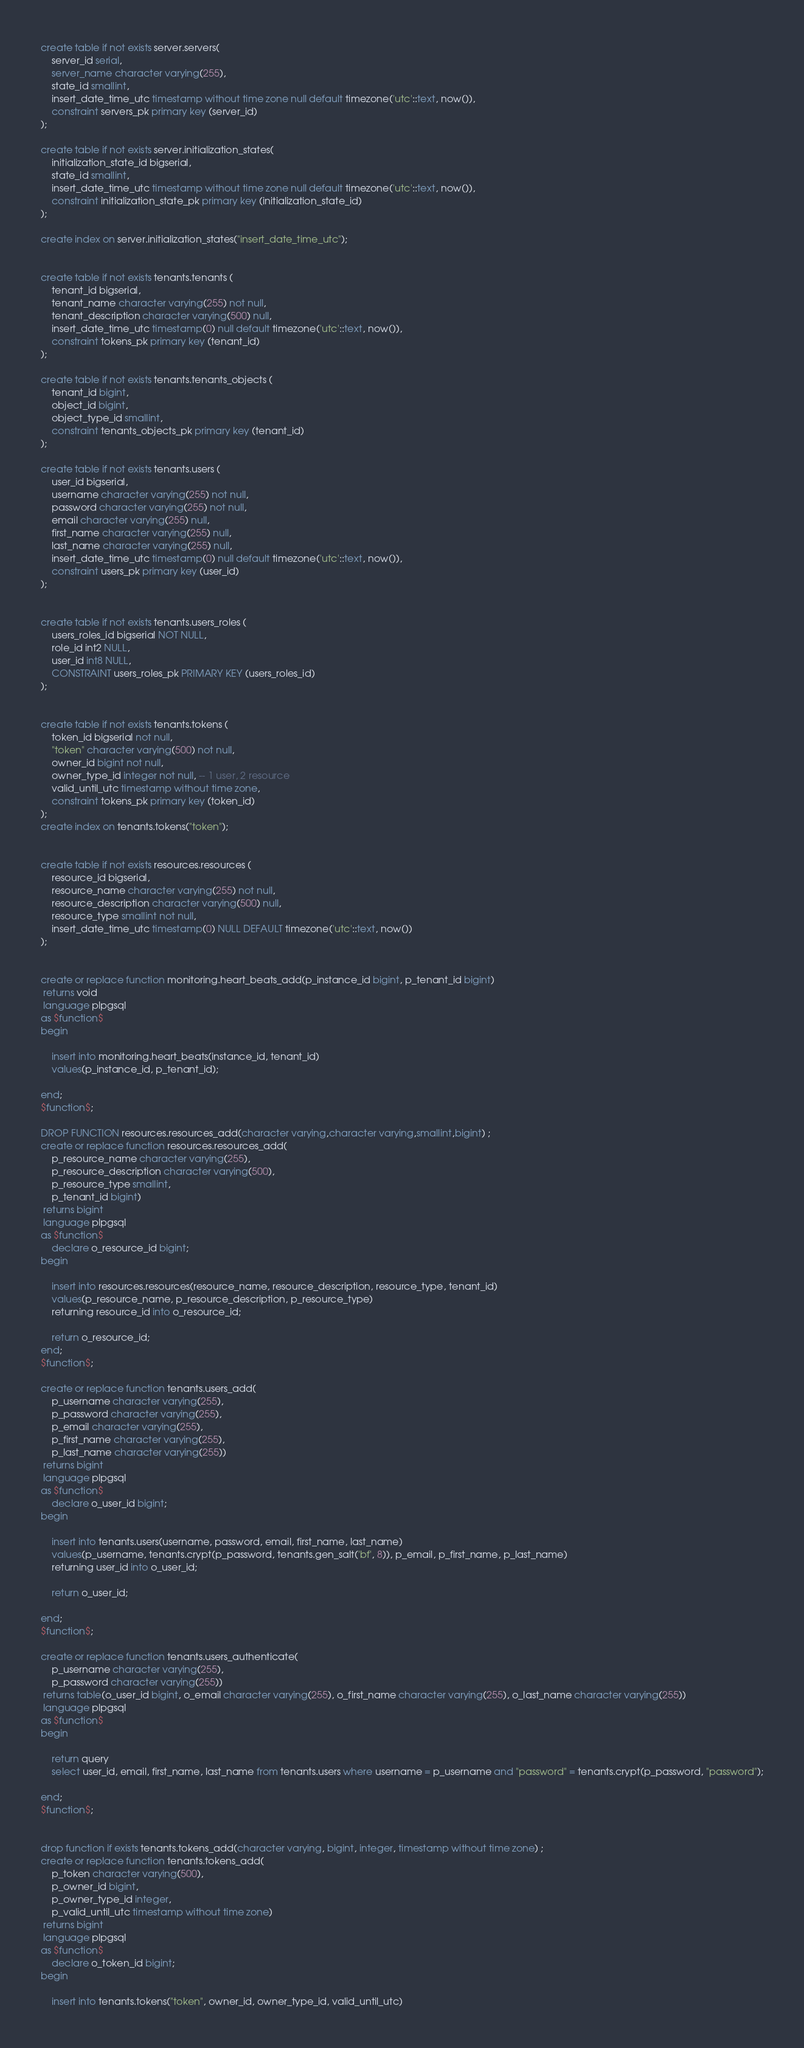Convert code to text. <code><loc_0><loc_0><loc_500><loc_500><_SQL_>create table if not exists server.servers(
	server_id serial,
	server_name character varying(255),
	state_id smallint,
	insert_date_time_utc timestamp without time zone null default timezone('utc'::text, now()),
	constraint servers_pk primary key (server_id)
);

create table if not exists server.initialization_states(
	initialization_state_id bigserial,
	state_id smallint,
	insert_date_time_utc timestamp without time zone null default timezone('utc'::text, now()),
	constraint initialization_state_pk primary key (initialization_state_id)
);

create index on server.initialization_states("insert_date_time_utc");


create table if not exists tenants.tenants (
	tenant_id bigserial,
	tenant_name character varying(255) not null,
	tenant_description character varying(500) null,
	insert_date_time_utc timestamp(0) null default timezone('utc'::text, now()),
	constraint tokens_pk primary key (tenant_id)
);

create table if not exists tenants.tenants_objects (
	tenant_id bigint,
	object_id bigint,
	object_type_id smallint,
	constraint tenants_objects_pk primary key (tenant_id)
);

create table if not exists tenants.users (
	user_id bigserial,
	username character varying(255) not null,
	password character varying(255) not null,
	email character varying(255) null,
	first_name character varying(255) null,
	last_name character varying(255) null,
	insert_date_time_utc timestamp(0) null default timezone('utc'::text, now()),
	constraint users_pk primary key (user_id)
);


create table if not exists tenants.users_roles (
	users_roles_id bigserial NOT NULL,
	role_id int2 NULL,
	user_id int8 NULL,
	CONSTRAINT users_roles_pk PRIMARY KEY (users_roles_id)
);


create table if not exists tenants.tokens (
	token_id bigserial not null,
	"token" character varying(500) not null,
	owner_id bigint not null,
	owner_type_id integer not null, -- 1 user, 2 resource
	valid_until_utc timestamp without time zone,
	constraint tokens_pk primary key (token_id)
);
create index on tenants.tokens("token");


create table if not exists resources.resources (
	resource_id bigserial,
	resource_name character varying(255) not null,
	resource_description character varying(500) null,
	resource_type smallint not null,
	insert_date_time_utc timestamp(0) NULL DEFAULT timezone('utc'::text, now())
);


create or replace function monitoring.heart_beats_add(p_instance_id bigint, p_tenant_id bigint)
 returns void
 language plpgsql
as $function$
begin

	insert into monitoring.heart_beats(instance_id, tenant_id)
	values(p_instance_id, p_tenant_id);

end;
$function$;

DROP FUNCTION resources.resources_add(character varying,character varying,smallint,bigint) ;
create or replace function resources.resources_add(
	p_resource_name character varying(255),
	p_resource_description character varying(500),
	p_resource_type smallint,
	p_tenant_id bigint)
 returns bigint
 language plpgsql
as $function$
	declare o_resource_id bigint;
begin

	insert into resources.resources(resource_name, resource_description, resource_type, tenant_id)
	values(p_resource_name, p_resource_description, p_resource_type)
	returning resource_id into o_resource_id;

	return o_resource_id;
end;
$function$;

create or replace function tenants.users_add(
	p_username character varying(255),
	p_password character varying(255),
	p_email character varying(255),
	p_first_name character varying(255),
	p_last_name character varying(255))
 returns bigint
 language plpgsql
as $function$
	declare o_user_id bigint;
begin

	insert into tenants.users(username, password, email, first_name, last_name)
	values(p_username, tenants.crypt(p_password, tenants.gen_salt('bf', 8)), p_email, p_first_name, p_last_name)
	returning user_id into o_user_id;

	return o_user_id;

end;
$function$;

create or replace function tenants.users_authenticate(
	p_username character varying(255),
	p_password character varying(255))
 returns table(o_user_id bigint, o_email character varying(255), o_first_name character varying(255), o_last_name character varying(255))
 language plpgsql
as $function$
begin

	return query
	select user_id, email, first_name, last_name from tenants.users where username = p_username and "password" = tenants.crypt(p_password, "password");

end;
$function$;


drop function if exists tenants.tokens_add(character varying, bigint, integer, timestamp without time zone) ;
create or replace function tenants.tokens_add(
	p_token character varying(500), 
	p_owner_id bigint, 
	p_owner_type_id integer, 
	p_valid_until_utc timestamp without time zone)
 returns bigint
 language plpgsql
as $function$
	declare o_token_id bigint;
begin

	insert into tenants.tokens("token", owner_id, owner_type_id, valid_until_utc)</code> 